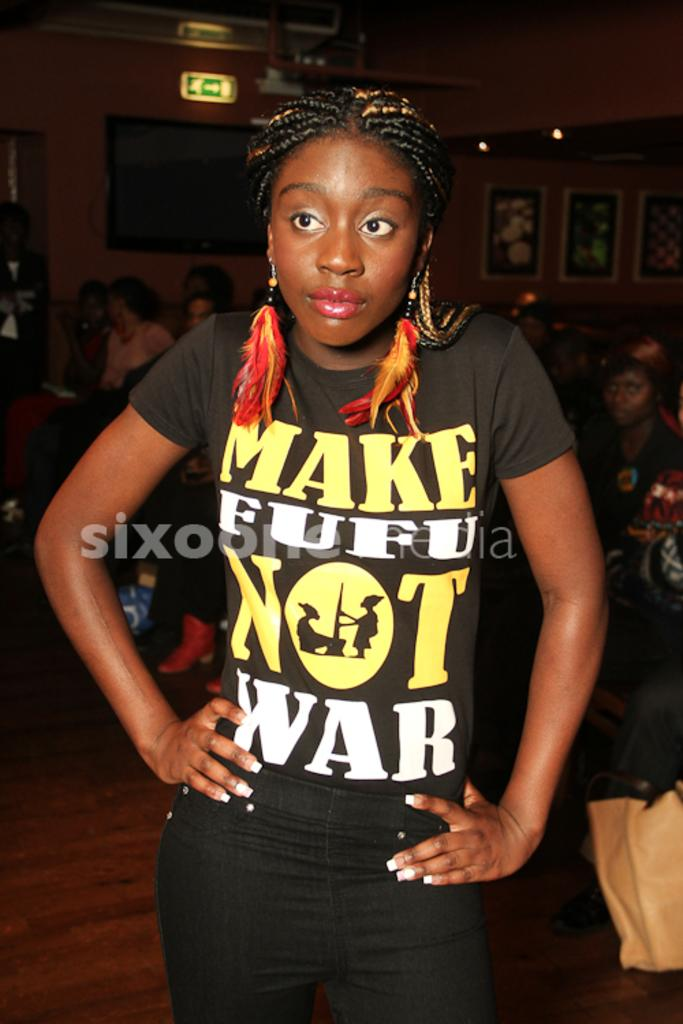<image>
Provide a brief description of the given image. A woman stands hands on hips wearing a black top emblazened with the words Make Fufu Not War 